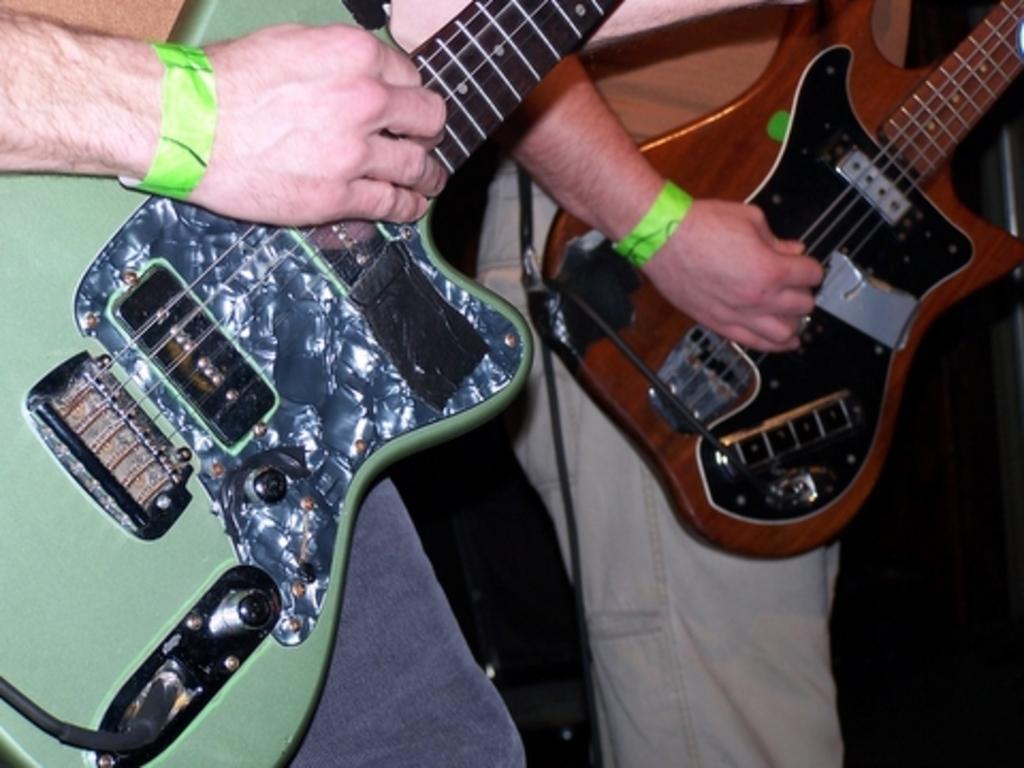Please provide a concise description of this image. In the image two persons are playing guitar. In the left side there is a green guitar , in the right side there is a brown guitar. The persons are wearing green wristband. 